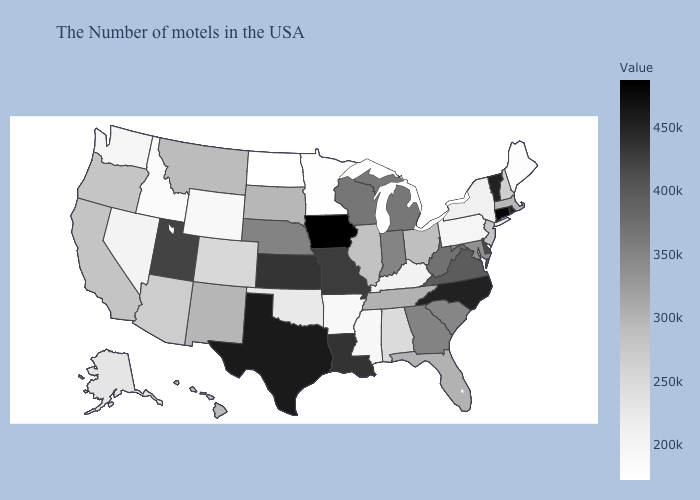Among the states that border Virginia , which have the lowest value?
Keep it brief. Kentucky. Among the states that border Alabama , which have the lowest value?
Quick response, please. Mississippi. Does Rhode Island have a lower value than Iowa?
Write a very short answer. Yes. Does New Hampshire have the lowest value in the Northeast?
Keep it brief. No. 